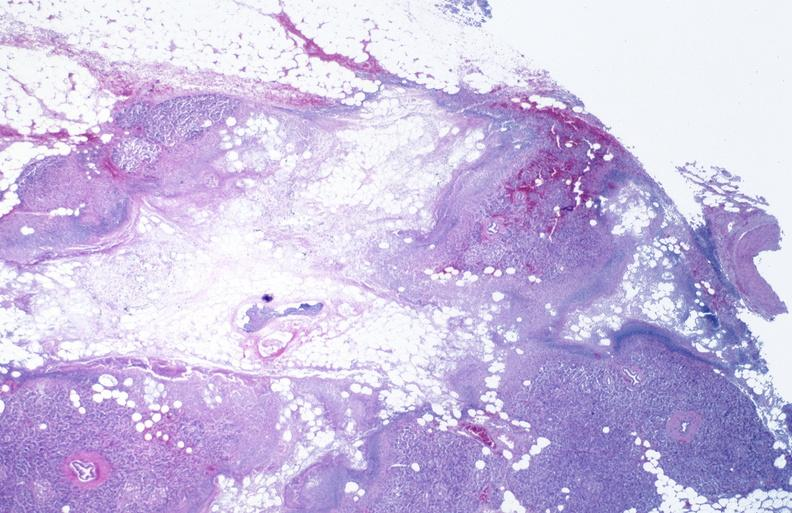what does this image show?
Answer the question using a single word or phrase. Pancreatic fat necrosis 